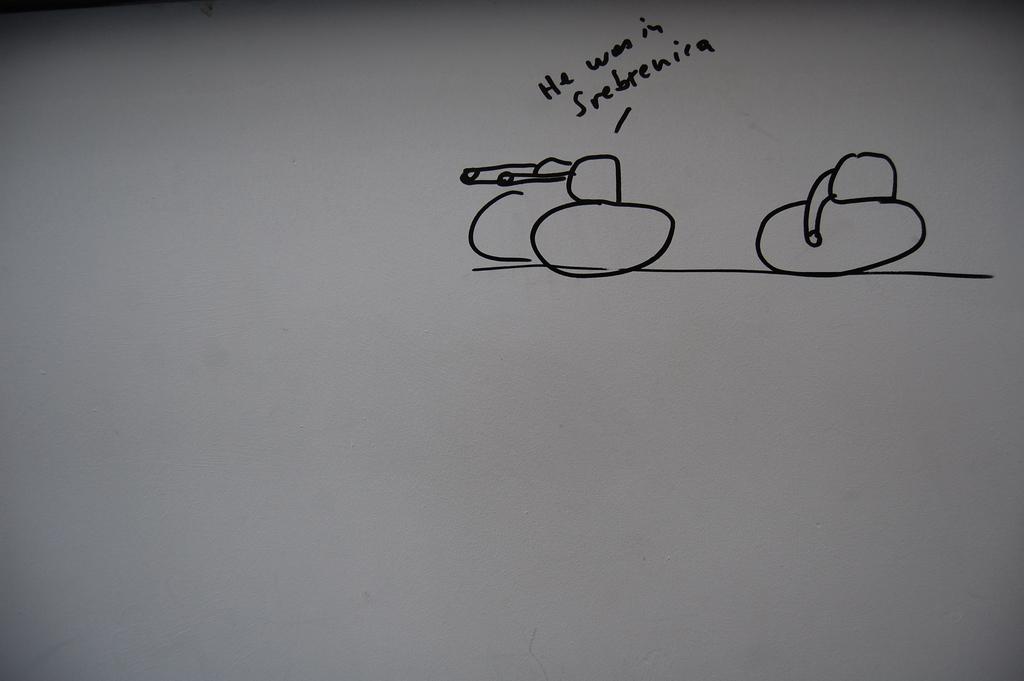What is the first word written here?
Ensure brevity in your answer.  He. 